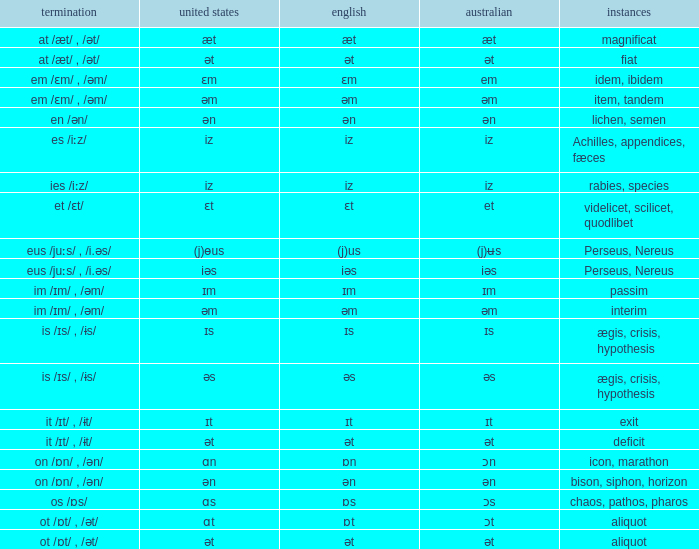Which British has Examples of exit? Ɪt. 